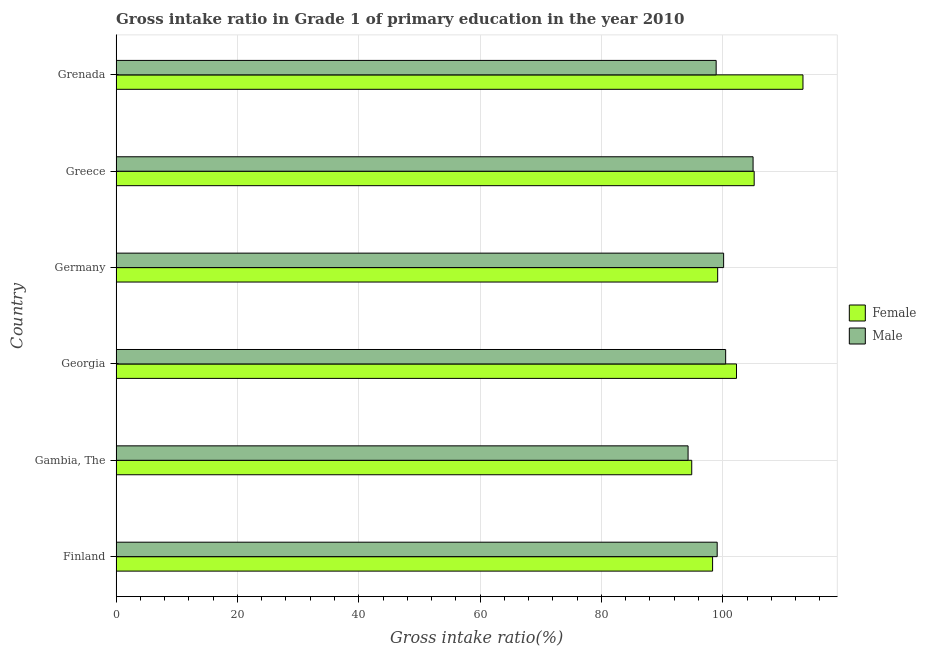How many groups of bars are there?
Provide a succinct answer. 6. Are the number of bars per tick equal to the number of legend labels?
Your answer should be very brief. Yes. Are the number of bars on each tick of the Y-axis equal?
Your response must be concise. Yes. How many bars are there on the 4th tick from the top?
Provide a short and direct response. 2. In how many cases, is the number of bars for a given country not equal to the number of legend labels?
Ensure brevity in your answer.  0. What is the gross intake ratio(female) in Gambia, The?
Offer a very short reply. 94.88. Across all countries, what is the maximum gross intake ratio(female)?
Offer a terse response. 113.22. Across all countries, what is the minimum gross intake ratio(male)?
Provide a succinct answer. 94.28. In which country was the gross intake ratio(female) maximum?
Keep it short and to the point. Grenada. In which country was the gross intake ratio(female) minimum?
Offer a terse response. Gambia, The. What is the total gross intake ratio(female) in the graph?
Your response must be concise. 613.02. What is the difference between the gross intake ratio(male) in Gambia, The and that in Georgia?
Give a very brief answer. -6.19. What is the difference between the gross intake ratio(female) in Grenada and the gross intake ratio(male) in Gambia, The?
Ensure brevity in your answer.  18.94. What is the average gross intake ratio(female) per country?
Your answer should be compact. 102.17. What is the difference between the gross intake ratio(male) and gross intake ratio(female) in Gambia, The?
Your response must be concise. -0.6. What is the ratio of the gross intake ratio(female) in Finland to that in Germany?
Offer a terse response. 0.99. What is the difference between the highest and the second highest gross intake ratio(male)?
Your response must be concise. 4.52. What is the difference between the highest and the lowest gross intake ratio(female)?
Give a very brief answer. 18.33. In how many countries, is the gross intake ratio(male) greater than the average gross intake ratio(male) taken over all countries?
Offer a very short reply. 3. What does the 1st bar from the bottom in Greece represents?
Make the answer very short. Female. How many bars are there?
Keep it short and to the point. 12. Are the values on the major ticks of X-axis written in scientific E-notation?
Keep it short and to the point. No. Does the graph contain any zero values?
Give a very brief answer. No. Does the graph contain grids?
Provide a succinct answer. Yes. Where does the legend appear in the graph?
Give a very brief answer. Center right. What is the title of the graph?
Your answer should be very brief. Gross intake ratio in Grade 1 of primary education in the year 2010. Does "Age 65(male)" appear as one of the legend labels in the graph?
Your answer should be very brief. No. What is the label or title of the X-axis?
Your answer should be compact. Gross intake ratio(%). What is the Gross intake ratio(%) in Female in Finland?
Your response must be concise. 98.32. What is the Gross intake ratio(%) in Male in Finland?
Give a very brief answer. 99.08. What is the Gross intake ratio(%) of Female in Gambia, The?
Provide a succinct answer. 94.88. What is the Gross intake ratio(%) in Male in Gambia, The?
Provide a short and direct response. 94.28. What is the Gross intake ratio(%) of Female in Georgia?
Your answer should be compact. 102.26. What is the Gross intake ratio(%) in Male in Georgia?
Give a very brief answer. 100.48. What is the Gross intake ratio(%) of Female in Germany?
Your answer should be compact. 99.16. What is the Gross intake ratio(%) of Male in Germany?
Make the answer very short. 100.14. What is the Gross intake ratio(%) of Female in Greece?
Offer a very short reply. 105.18. What is the Gross intake ratio(%) in Male in Greece?
Make the answer very short. 104.99. What is the Gross intake ratio(%) in Female in Grenada?
Give a very brief answer. 113.22. What is the Gross intake ratio(%) of Male in Grenada?
Keep it short and to the point. 98.91. Across all countries, what is the maximum Gross intake ratio(%) of Female?
Ensure brevity in your answer.  113.22. Across all countries, what is the maximum Gross intake ratio(%) in Male?
Provide a succinct answer. 104.99. Across all countries, what is the minimum Gross intake ratio(%) in Female?
Offer a terse response. 94.88. Across all countries, what is the minimum Gross intake ratio(%) in Male?
Make the answer very short. 94.28. What is the total Gross intake ratio(%) of Female in the graph?
Give a very brief answer. 613.02. What is the total Gross intake ratio(%) in Male in the graph?
Make the answer very short. 597.88. What is the difference between the Gross intake ratio(%) in Female in Finland and that in Gambia, The?
Offer a terse response. 3.44. What is the difference between the Gross intake ratio(%) in Male in Finland and that in Gambia, The?
Offer a terse response. 4.8. What is the difference between the Gross intake ratio(%) of Female in Finland and that in Georgia?
Offer a terse response. -3.94. What is the difference between the Gross intake ratio(%) of Male in Finland and that in Georgia?
Your answer should be compact. -1.4. What is the difference between the Gross intake ratio(%) of Female in Finland and that in Germany?
Offer a very short reply. -0.84. What is the difference between the Gross intake ratio(%) of Male in Finland and that in Germany?
Your answer should be compact. -1.06. What is the difference between the Gross intake ratio(%) of Female in Finland and that in Greece?
Keep it short and to the point. -6.86. What is the difference between the Gross intake ratio(%) in Male in Finland and that in Greece?
Provide a short and direct response. -5.92. What is the difference between the Gross intake ratio(%) of Female in Finland and that in Grenada?
Provide a succinct answer. -14.9. What is the difference between the Gross intake ratio(%) of Male in Finland and that in Grenada?
Provide a short and direct response. 0.17. What is the difference between the Gross intake ratio(%) of Female in Gambia, The and that in Georgia?
Make the answer very short. -7.38. What is the difference between the Gross intake ratio(%) in Male in Gambia, The and that in Georgia?
Provide a short and direct response. -6.19. What is the difference between the Gross intake ratio(%) of Female in Gambia, The and that in Germany?
Keep it short and to the point. -4.27. What is the difference between the Gross intake ratio(%) in Male in Gambia, The and that in Germany?
Your answer should be very brief. -5.86. What is the difference between the Gross intake ratio(%) in Female in Gambia, The and that in Greece?
Provide a short and direct response. -10.29. What is the difference between the Gross intake ratio(%) of Male in Gambia, The and that in Greece?
Keep it short and to the point. -10.71. What is the difference between the Gross intake ratio(%) of Female in Gambia, The and that in Grenada?
Give a very brief answer. -18.33. What is the difference between the Gross intake ratio(%) of Male in Gambia, The and that in Grenada?
Offer a terse response. -4.63. What is the difference between the Gross intake ratio(%) of Female in Georgia and that in Germany?
Provide a succinct answer. 3.1. What is the difference between the Gross intake ratio(%) of Male in Georgia and that in Germany?
Offer a terse response. 0.34. What is the difference between the Gross intake ratio(%) in Female in Georgia and that in Greece?
Your answer should be compact. -2.91. What is the difference between the Gross intake ratio(%) in Male in Georgia and that in Greece?
Provide a short and direct response. -4.52. What is the difference between the Gross intake ratio(%) in Female in Georgia and that in Grenada?
Your answer should be compact. -10.96. What is the difference between the Gross intake ratio(%) of Male in Georgia and that in Grenada?
Keep it short and to the point. 1.57. What is the difference between the Gross intake ratio(%) of Female in Germany and that in Greece?
Ensure brevity in your answer.  -6.02. What is the difference between the Gross intake ratio(%) in Male in Germany and that in Greece?
Ensure brevity in your answer.  -4.85. What is the difference between the Gross intake ratio(%) of Female in Germany and that in Grenada?
Provide a succinct answer. -14.06. What is the difference between the Gross intake ratio(%) in Male in Germany and that in Grenada?
Your answer should be compact. 1.23. What is the difference between the Gross intake ratio(%) of Female in Greece and that in Grenada?
Your response must be concise. -8.04. What is the difference between the Gross intake ratio(%) in Male in Greece and that in Grenada?
Provide a succinct answer. 6.09. What is the difference between the Gross intake ratio(%) of Female in Finland and the Gross intake ratio(%) of Male in Gambia, The?
Keep it short and to the point. 4.04. What is the difference between the Gross intake ratio(%) in Female in Finland and the Gross intake ratio(%) in Male in Georgia?
Offer a very short reply. -2.15. What is the difference between the Gross intake ratio(%) of Female in Finland and the Gross intake ratio(%) of Male in Germany?
Your response must be concise. -1.82. What is the difference between the Gross intake ratio(%) in Female in Finland and the Gross intake ratio(%) in Male in Greece?
Offer a very short reply. -6.67. What is the difference between the Gross intake ratio(%) in Female in Finland and the Gross intake ratio(%) in Male in Grenada?
Offer a very short reply. -0.59. What is the difference between the Gross intake ratio(%) of Female in Gambia, The and the Gross intake ratio(%) of Male in Georgia?
Your answer should be compact. -5.59. What is the difference between the Gross intake ratio(%) in Female in Gambia, The and the Gross intake ratio(%) in Male in Germany?
Provide a succinct answer. -5.26. What is the difference between the Gross intake ratio(%) of Female in Gambia, The and the Gross intake ratio(%) of Male in Greece?
Offer a terse response. -10.11. What is the difference between the Gross intake ratio(%) in Female in Gambia, The and the Gross intake ratio(%) in Male in Grenada?
Offer a terse response. -4.02. What is the difference between the Gross intake ratio(%) of Female in Georgia and the Gross intake ratio(%) of Male in Germany?
Provide a succinct answer. 2.12. What is the difference between the Gross intake ratio(%) of Female in Georgia and the Gross intake ratio(%) of Male in Greece?
Keep it short and to the point. -2.73. What is the difference between the Gross intake ratio(%) in Female in Georgia and the Gross intake ratio(%) in Male in Grenada?
Your answer should be compact. 3.35. What is the difference between the Gross intake ratio(%) of Female in Germany and the Gross intake ratio(%) of Male in Greece?
Make the answer very short. -5.84. What is the difference between the Gross intake ratio(%) in Female in Germany and the Gross intake ratio(%) in Male in Grenada?
Your answer should be compact. 0.25. What is the difference between the Gross intake ratio(%) of Female in Greece and the Gross intake ratio(%) of Male in Grenada?
Offer a terse response. 6.27. What is the average Gross intake ratio(%) of Female per country?
Offer a very short reply. 102.17. What is the average Gross intake ratio(%) of Male per country?
Your response must be concise. 99.65. What is the difference between the Gross intake ratio(%) in Female and Gross intake ratio(%) in Male in Finland?
Give a very brief answer. -0.76. What is the difference between the Gross intake ratio(%) in Female and Gross intake ratio(%) in Male in Gambia, The?
Your response must be concise. 0.6. What is the difference between the Gross intake ratio(%) of Female and Gross intake ratio(%) of Male in Georgia?
Offer a terse response. 1.79. What is the difference between the Gross intake ratio(%) in Female and Gross intake ratio(%) in Male in Germany?
Provide a succinct answer. -0.98. What is the difference between the Gross intake ratio(%) of Female and Gross intake ratio(%) of Male in Greece?
Provide a short and direct response. 0.18. What is the difference between the Gross intake ratio(%) of Female and Gross intake ratio(%) of Male in Grenada?
Make the answer very short. 14.31. What is the ratio of the Gross intake ratio(%) of Female in Finland to that in Gambia, The?
Your answer should be very brief. 1.04. What is the ratio of the Gross intake ratio(%) in Male in Finland to that in Gambia, The?
Keep it short and to the point. 1.05. What is the ratio of the Gross intake ratio(%) of Female in Finland to that in Georgia?
Your response must be concise. 0.96. What is the ratio of the Gross intake ratio(%) in Male in Finland to that in Georgia?
Provide a short and direct response. 0.99. What is the ratio of the Gross intake ratio(%) of Female in Finland to that in Germany?
Make the answer very short. 0.99. What is the ratio of the Gross intake ratio(%) of Female in Finland to that in Greece?
Provide a succinct answer. 0.93. What is the ratio of the Gross intake ratio(%) of Male in Finland to that in Greece?
Your answer should be very brief. 0.94. What is the ratio of the Gross intake ratio(%) of Female in Finland to that in Grenada?
Ensure brevity in your answer.  0.87. What is the ratio of the Gross intake ratio(%) of Female in Gambia, The to that in Georgia?
Give a very brief answer. 0.93. What is the ratio of the Gross intake ratio(%) in Male in Gambia, The to that in Georgia?
Offer a very short reply. 0.94. What is the ratio of the Gross intake ratio(%) in Female in Gambia, The to that in Germany?
Ensure brevity in your answer.  0.96. What is the ratio of the Gross intake ratio(%) in Male in Gambia, The to that in Germany?
Provide a succinct answer. 0.94. What is the ratio of the Gross intake ratio(%) of Female in Gambia, The to that in Greece?
Your answer should be very brief. 0.9. What is the ratio of the Gross intake ratio(%) in Male in Gambia, The to that in Greece?
Your response must be concise. 0.9. What is the ratio of the Gross intake ratio(%) of Female in Gambia, The to that in Grenada?
Ensure brevity in your answer.  0.84. What is the ratio of the Gross intake ratio(%) in Male in Gambia, The to that in Grenada?
Provide a succinct answer. 0.95. What is the ratio of the Gross intake ratio(%) of Female in Georgia to that in Germany?
Keep it short and to the point. 1.03. What is the ratio of the Gross intake ratio(%) of Male in Georgia to that in Germany?
Your response must be concise. 1. What is the ratio of the Gross intake ratio(%) of Female in Georgia to that in Greece?
Offer a terse response. 0.97. What is the ratio of the Gross intake ratio(%) in Male in Georgia to that in Greece?
Ensure brevity in your answer.  0.96. What is the ratio of the Gross intake ratio(%) in Female in Georgia to that in Grenada?
Make the answer very short. 0.9. What is the ratio of the Gross intake ratio(%) in Male in Georgia to that in Grenada?
Provide a short and direct response. 1.02. What is the ratio of the Gross intake ratio(%) of Female in Germany to that in Greece?
Offer a terse response. 0.94. What is the ratio of the Gross intake ratio(%) in Male in Germany to that in Greece?
Your answer should be compact. 0.95. What is the ratio of the Gross intake ratio(%) of Female in Germany to that in Grenada?
Your answer should be compact. 0.88. What is the ratio of the Gross intake ratio(%) of Male in Germany to that in Grenada?
Provide a succinct answer. 1.01. What is the ratio of the Gross intake ratio(%) of Female in Greece to that in Grenada?
Your answer should be very brief. 0.93. What is the ratio of the Gross intake ratio(%) in Male in Greece to that in Grenada?
Your response must be concise. 1.06. What is the difference between the highest and the second highest Gross intake ratio(%) in Female?
Your answer should be very brief. 8.04. What is the difference between the highest and the second highest Gross intake ratio(%) of Male?
Keep it short and to the point. 4.52. What is the difference between the highest and the lowest Gross intake ratio(%) in Female?
Provide a short and direct response. 18.33. What is the difference between the highest and the lowest Gross intake ratio(%) in Male?
Make the answer very short. 10.71. 